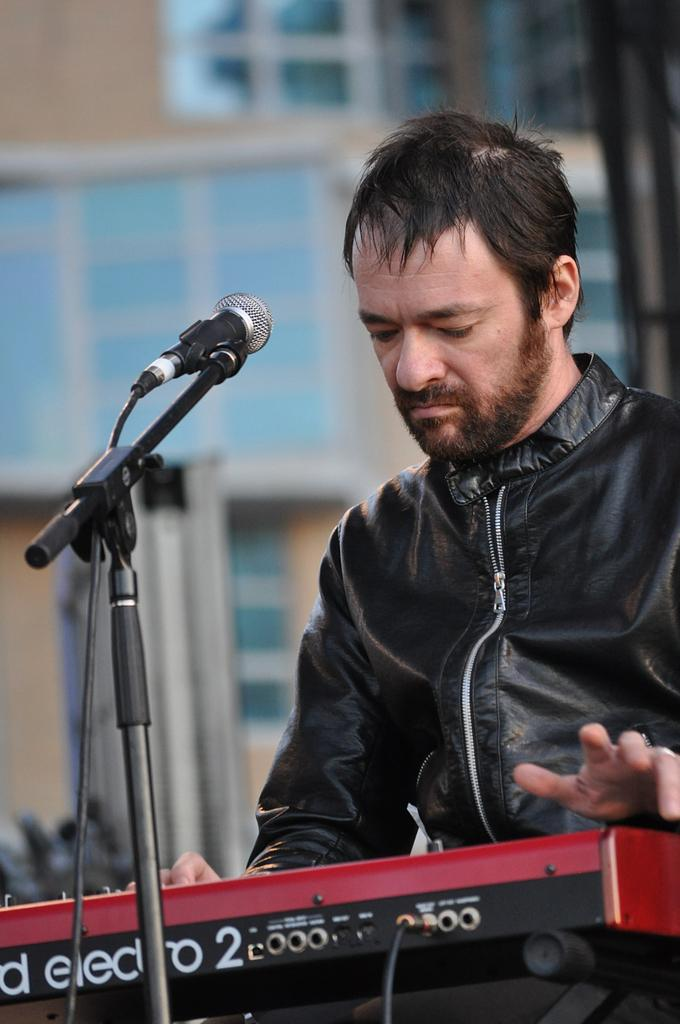What is the main subject of the image? There is a person in the image. What is the person wearing? The person is wearing a black jacket. What is the person doing in the image? The person is playing musical instruments. What is in front of the person? There is a microphone in front of the person. What can be seen in the background of the image? There is a building in the background of the image. What type of wool can be seen on the street in the image? There is no wool or street present in the image; it features a person playing musical instruments with a microphone in front of them and a building in the background. 